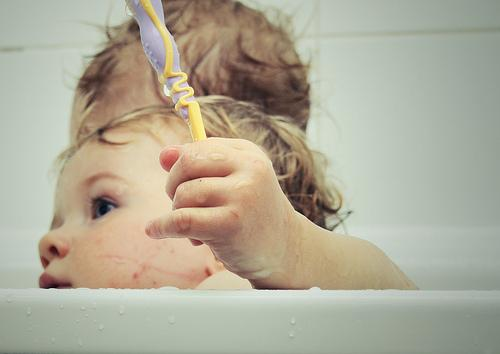What is the baby sitting holding? Please explain your reasoning. toothbrush. The baby is holding the handle of a purple and yellow toothbrush. 